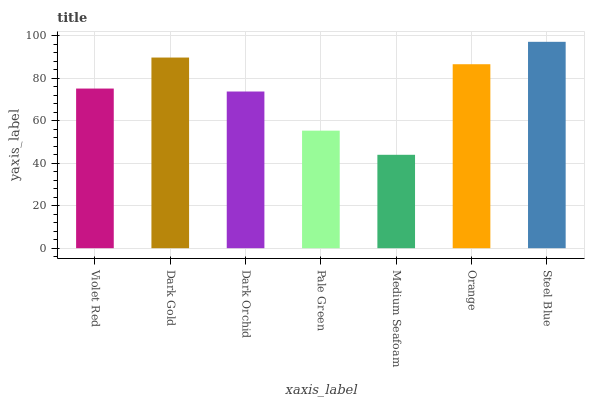Is Dark Gold the minimum?
Answer yes or no. No. Is Dark Gold the maximum?
Answer yes or no. No. Is Dark Gold greater than Violet Red?
Answer yes or no. Yes. Is Violet Red less than Dark Gold?
Answer yes or no. Yes. Is Violet Red greater than Dark Gold?
Answer yes or no. No. Is Dark Gold less than Violet Red?
Answer yes or no. No. Is Violet Red the high median?
Answer yes or no. Yes. Is Violet Red the low median?
Answer yes or no. Yes. Is Steel Blue the high median?
Answer yes or no. No. Is Dark Orchid the low median?
Answer yes or no. No. 